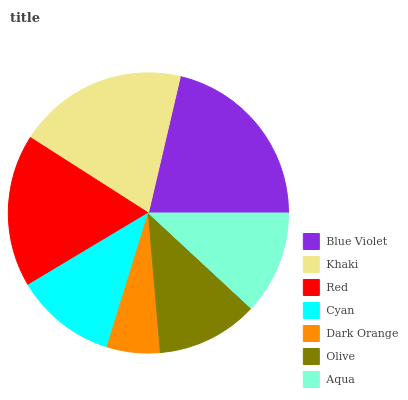Is Dark Orange the minimum?
Answer yes or no. Yes. Is Blue Violet the maximum?
Answer yes or no. Yes. Is Khaki the minimum?
Answer yes or no. No. Is Khaki the maximum?
Answer yes or no. No. Is Blue Violet greater than Khaki?
Answer yes or no. Yes. Is Khaki less than Blue Violet?
Answer yes or no. Yes. Is Khaki greater than Blue Violet?
Answer yes or no. No. Is Blue Violet less than Khaki?
Answer yes or no. No. Is Aqua the high median?
Answer yes or no. Yes. Is Aqua the low median?
Answer yes or no. Yes. Is Khaki the high median?
Answer yes or no. No. Is Cyan the low median?
Answer yes or no. No. 